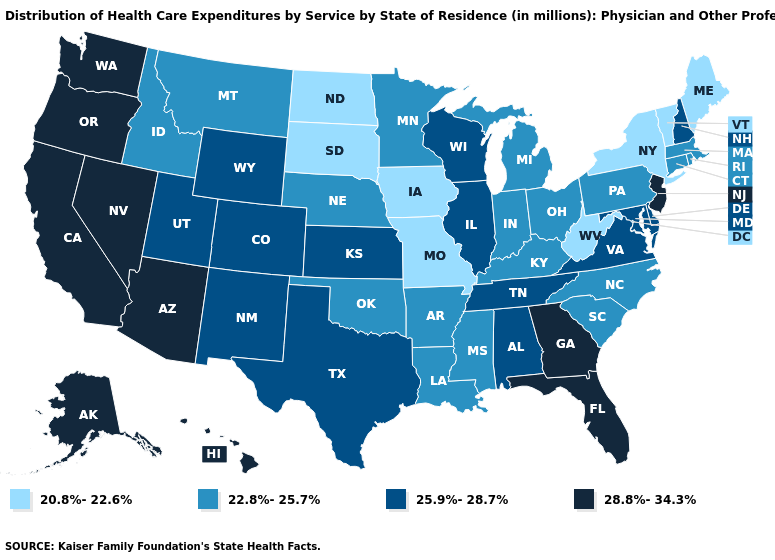Among the states that border Minnesota , does South Dakota have the lowest value?
Short answer required. Yes. Among the states that border North Dakota , does South Dakota have the highest value?
Short answer required. No. What is the value of Connecticut?
Short answer required. 22.8%-25.7%. Name the states that have a value in the range 25.9%-28.7%?
Write a very short answer. Alabama, Colorado, Delaware, Illinois, Kansas, Maryland, New Hampshire, New Mexico, Tennessee, Texas, Utah, Virginia, Wisconsin, Wyoming. Name the states that have a value in the range 20.8%-22.6%?
Be succinct. Iowa, Maine, Missouri, New York, North Dakota, South Dakota, Vermont, West Virginia. What is the value of Indiana?
Answer briefly. 22.8%-25.7%. How many symbols are there in the legend?
Keep it brief. 4. What is the value of New Hampshire?
Be succinct. 25.9%-28.7%. Does Ohio have the same value as Vermont?
Keep it brief. No. Among the states that border West Virginia , does Maryland have the lowest value?
Answer briefly. No. Name the states that have a value in the range 20.8%-22.6%?
Keep it brief. Iowa, Maine, Missouri, New York, North Dakota, South Dakota, Vermont, West Virginia. What is the highest value in the USA?
Concise answer only. 28.8%-34.3%. What is the value of West Virginia?
Answer briefly. 20.8%-22.6%. Does the first symbol in the legend represent the smallest category?
Concise answer only. Yes. Among the states that border Wyoming , which have the lowest value?
Concise answer only. South Dakota. 